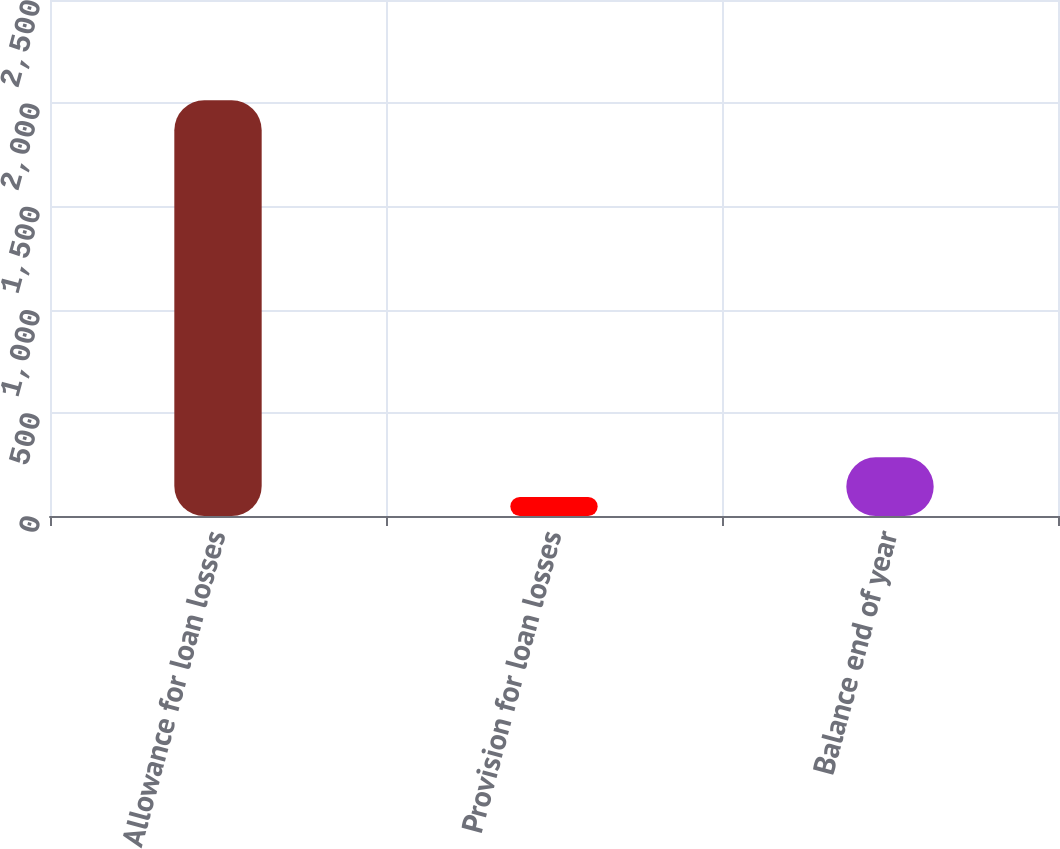Convert chart. <chart><loc_0><loc_0><loc_500><loc_500><bar_chart><fcel>Allowance for loan losses<fcel>Provision for loan losses<fcel>Balance end of year<nl><fcel>2014<fcel>92<fcel>284.2<nl></chart> 